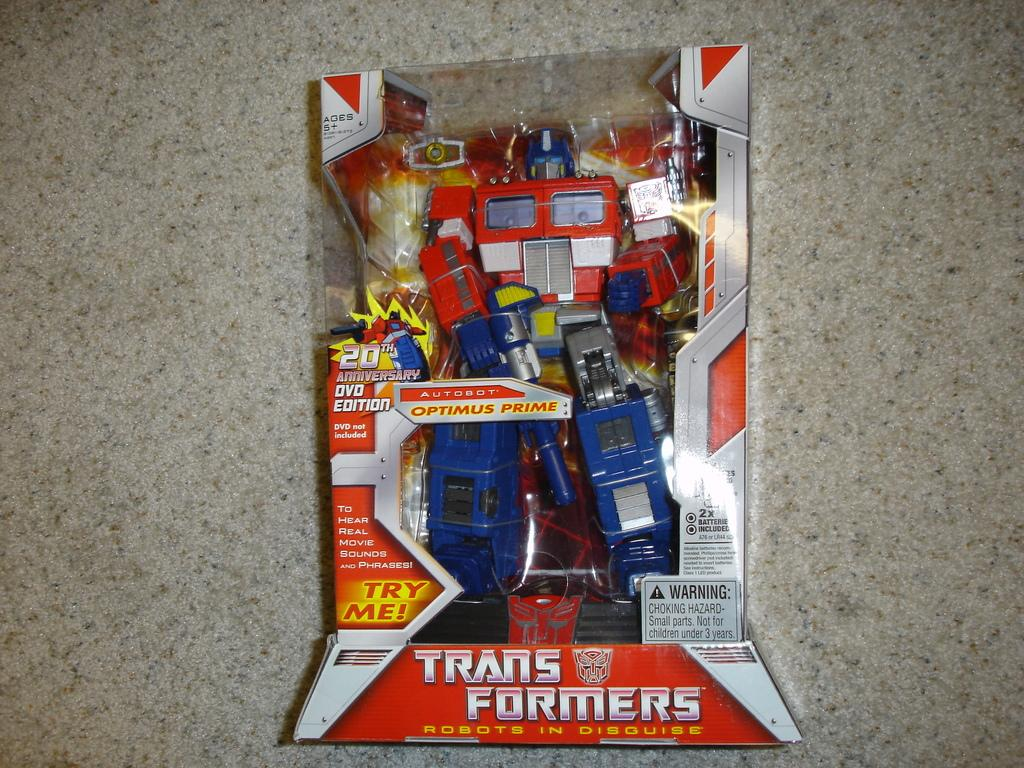<image>
Relay a brief, clear account of the picture shown. A transformers figurine looks pristine inside of its box 